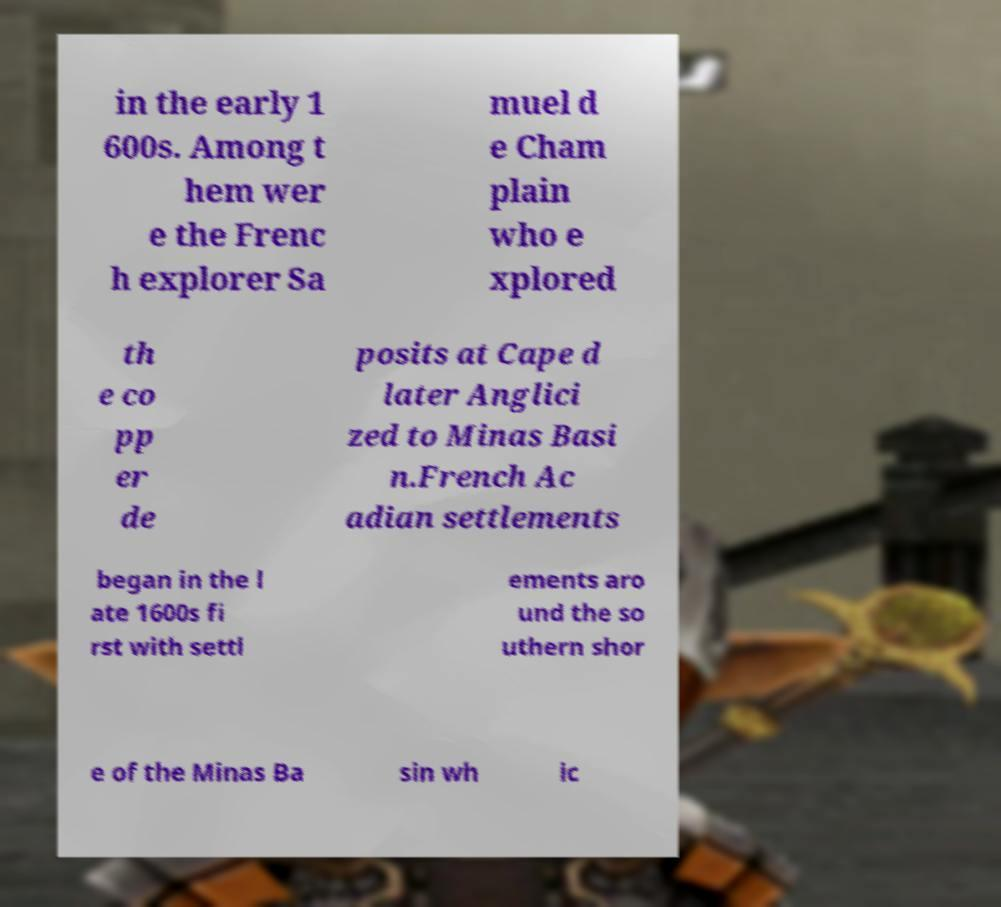Please read and relay the text visible in this image. What does it say? in the early 1 600s. Among t hem wer e the Frenc h explorer Sa muel d e Cham plain who e xplored th e co pp er de posits at Cape d later Anglici zed to Minas Basi n.French Ac adian settlements began in the l ate 1600s fi rst with settl ements aro und the so uthern shor e of the Minas Ba sin wh ic 